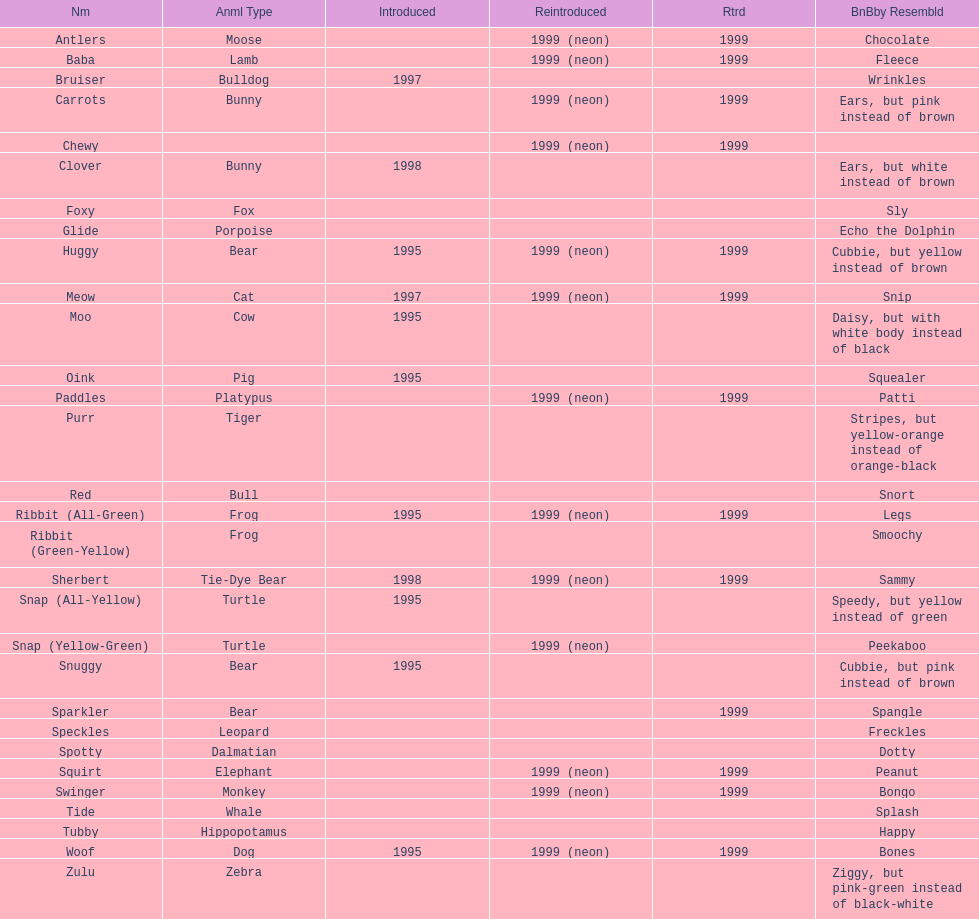How many total pillow pals were both reintroduced and retired in 1999? 12. 